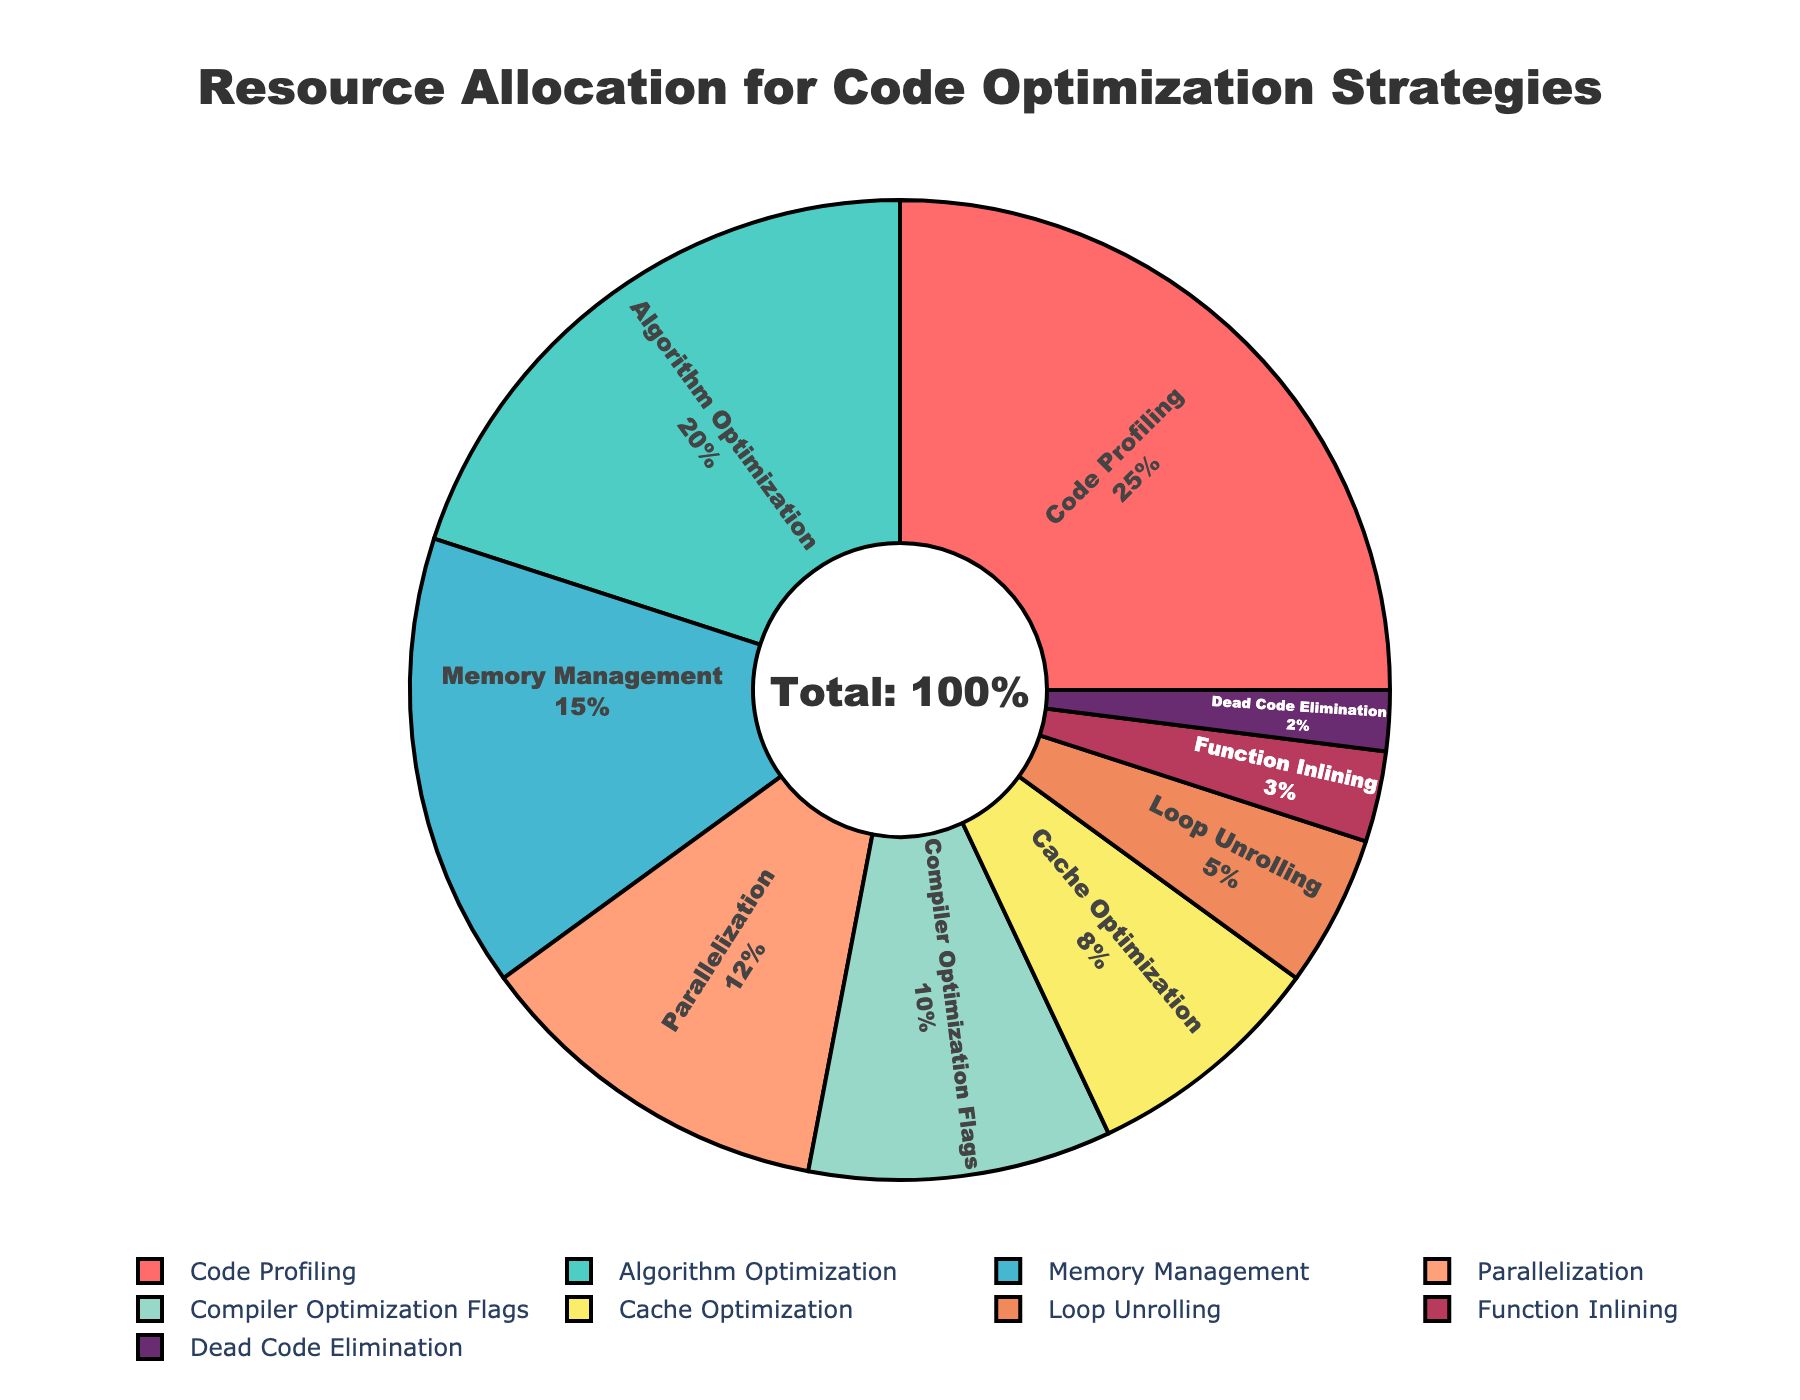What is the percentage of resources allocated to Algorithm Optimization compared to Compiler Optimization Flags? The percentage of Algorithm Optimization is 20%, and the percentage for Compiler Optimization Flags is 10%. By comparing the two percentages, Algorithm Optimization receives 10% more resources than Compiler Optimization Flags.
Answer: 10% How much more resources are allocated to Code Profiling compared to Cache Optimization? Code Profiling has 25% allocation, while Cache Optimization has 8%. The difference is calculated by subtracting 8% from 25%, resulting in a 17% difference.
Answer: 17% What is the combined percentage of resources allocated for Parallelization and Memory Management strategies? Parallelization is allocated 12% and Memory Management is allocated 15%. Adding these two percentages together gives 12% + 15% = 27%.
Answer: 27% Which strategy has the least resource allocation and what is its percentage? By examining the allocations, Dead Code Elimination has the lowest percentage at 2%.
Answer: Dead Code Elimination, 2% By how much does the allocation for Loop Unrolling exceed that for Function Inlining? Loop Unrolling is allocated 5% while Function Inlining is allocated 3%. Subtract 3% from 5% to find the difference, which is 2%.
Answer: 2% What percentage of resources is allocated to the top three strategies combined? The top three strategies by percentage are Code Profiling (25%), Algorithm Optimization (20%), and Memory Management (15%). Adding these amounts together gives 25% + 20% + 15% = 60%.
Answer: 60% Is the resource allocation for Memory Management greater than the combined allocation for Cache Optimization and Function Inlining? Memory Management is allocated 15%. The combined allocation for Cache Optimization (8%) and Function Inlining (3%) is 8% + 3% = 11%. Since 15% is greater than 11%, Memory Management has a higher allocation.
Answer: Yes What is the average percentage allocated to the four least-funded strategies? The four least-funded strategies are Loop Unrolling (5%), Function Inlining (3%), Dead Code Elimination (2%), and Cache Optimization (8%). The average percentage is calculated as (5% + 3% + 2% + 8%) / 4 = 18% / 4 = 4.5%.
Answer: 4.5% Which strategy uses more resources: Parallelization or Compiler Optimization Flags? Parallelization has a resource allocation of 12%, while Compiler Optimization Flags are allocated 10%. Since 12% is greater than 10%, Parallelization uses more resources.
Answer: Parallelization By what percentage do resources allocated to Code Profiling exceed the combined resources for Loop Unrolling and Function Inlining? Code Profiling is allocated 25%. The combined allocation for Loop Unrolling (5%) and Function Inlining (3%) is 5% + 3% = 8%. Subtracting 8% from 25% gives a difference of 17%.
Answer: 17% 